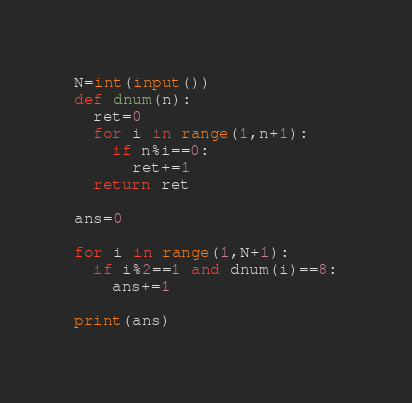Convert code to text. <code><loc_0><loc_0><loc_500><loc_500><_Python_>N=int(input())
def dnum(n):
  ret=0
  for i in range(1,n+1):
    if n%i==0:
      ret+=1
  return ret

ans=0

for i in range(1,N+1):
  if i%2==1 and dnum(i)==8:
    ans+=1

print(ans)
</code> 